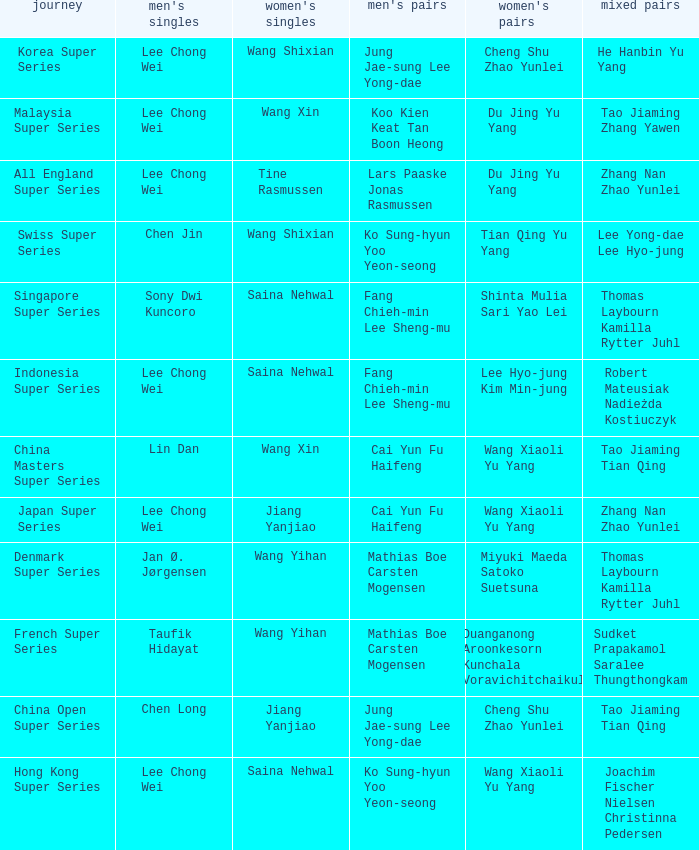Who is the mixed doubled on the tour korea super series? He Hanbin Yu Yang. 